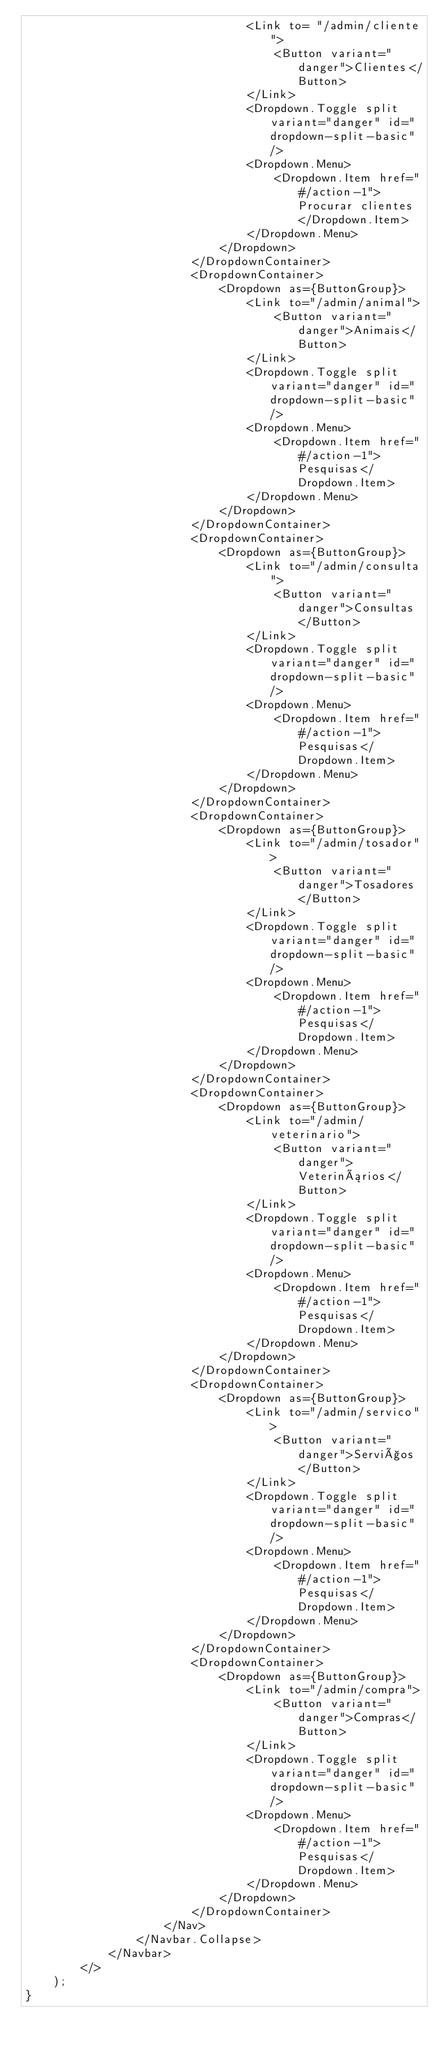<code> <loc_0><loc_0><loc_500><loc_500><_JavaScript_>                                <Link to= "/admin/cliente">
                                    <Button variant="danger">Clientes</Button>
                                </Link>
                                <Dropdown.Toggle split variant="danger" id="dropdown-split-basic" />
                                <Dropdown.Menu>
                                    <Dropdown.Item href="#/action-1">Procurar clientes</Dropdown.Item>
                                </Dropdown.Menu>
                            </Dropdown>
                        </DropdownContainer>
                        <DropdownContainer>                            
                            <Dropdown as={ButtonGroup}>
                                <Link to="/admin/animal">
                                    <Button variant="danger">Animais</Button>
                                </Link>
                                <Dropdown.Toggle split variant="danger" id="dropdown-split-basic" />
                                <Dropdown.Menu>
                                    <Dropdown.Item href="#/action-1">Pesquisas</Dropdown.Item>
                                </Dropdown.Menu>
                            </Dropdown>
                        </DropdownContainer>
                        <DropdownContainer>                            
                            <Dropdown as={ButtonGroup}>
                                <Link to="/admin/consulta">
                                    <Button variant="danger">Consultas</Button>
                                </Link>
                                <Dropdown.Toggle split variant="danger" id="dropdown-split-basic" />
                                <Dropdown.Menu>
                                    <Dropdown.Item href="#/action-1">Pesquisas</Dropdown.Item>
                                </Dropdown.Menu>
                            </Dropdown>
                        </DropdownContainer>
                        <DropdownContainer>                            
                            <Dropdown as={ButtonGroup}>
                                <Link to="/admin/tosador">
                                    <Button variant="danger">Tosadores</Button>
                                </Link>
                                <Dropdown.Toggle split variant="danger" id="dropdown-split-basic" />
                                <Dropdown.Menu>
                                    <Dropdown.Item href="#/action-1">Pesquisas</Dropdown.Item>
                                </Dropdown.Menu>
                            </Dropdown>
                        </DropdownContainer>
                        <DropdownContainer>                            
                            <Dropdown as={ButtonGroup}>
                                <Link to="/admin/veterinario">
                                    <Button variant="danger">Veterinários</Button>
                                </Link>
                                <Dropdown.Toggle split variant="danger" id="dropdown-split-basic" />
                                <Dropdown.Menu>
                                    <Dropdown.Item href="#/action-1">Pesquisas</Dropdown.Item>
                                </Dropdown.Menu>
                            </Dropdown>
                        </DropdownContainer>
                        <DropdownContainer>                            
                            <Dropdown as={ButtonGroup}>
                                <Link to="/admin/servico">
                                    <Button variant="danger">Serviços</Button>
                                </Link>
                                <Dropdown.Toggle split variant="danger" id="dropdown-split-basic" />
                                <Dropdown.Menu>
                                    <Dropdown.Item href="#/action-1">Pesquisas</Dropdown.Item>
                                </Dropdown.Menu>
                            </Dropdown>
                        </DropdownContainer>
                        <DropdownContainer>                            
                            <Dropdown as={ButtonGroup}>
                                <Link to="/admin/compra">
                                    <Button variant="danger">Compras</Button>
                                </Link>
                                <Dropdown.Toggle split variant="danger" id="dropdown-split-basic" />
                                <Dropdown.Menu>
                                    <Dropdown.Item href="#/action-1">Pesquisas</Dropdown.Item>
                                </Dropdown.Menu>
                            </Dropdown>
                        </DropdownContainer>
                    </Nav>
                </Navbar.Collapse>
            </Navbar>
        </>
    );
}</code> 